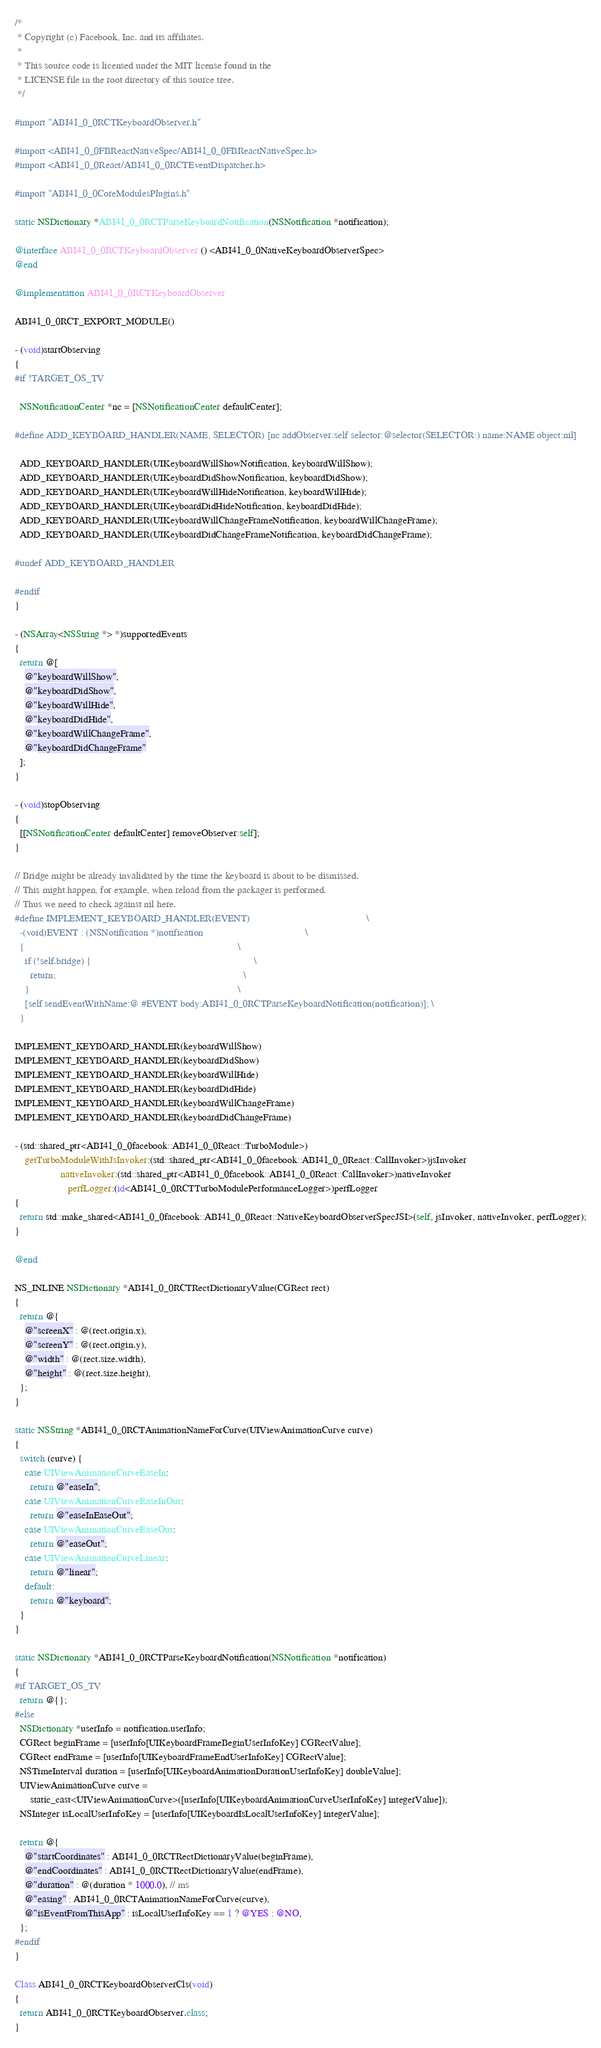<code> <loc_0><loc_0><loc_500><loc_500><_ObjectiveC_>/*
 * Copyright (c) Facebook, Inc. and its affiliates.
 *
 * This source code is licensed under the MIT license found in the
 * LICENSE file in the root directory of this source tree.
 */

#import "ABI41_0_0RCTKeyboardObserver.h"

#import <ABI41_0_0FBReactNativeSpec/ABI41_0_0FBReactNativeSpec.h>
#import <ABI41_0_0React/ABI41_0_0RCTEventDispatcher.h>

#import "ABI41_0_0CoreModulesPlugins.h"

static NSDictionary *ABI41_0_0RCTParseKeyboardNotification(NSNotification *notification);

@interface ABI41_0_0RCTKeyboardObserver () <ABI41_0_0NativeKeyboardObserverSpec>
@end

@implementation ABI41_0_0RCTKeyboardObserver

ABI41_0_0RCT_EXPORT_MODULE()

- (void)startObserving
{
#if !TARGET_OS_TV

  NSNotificationCenter *nc = [NSNotificationCenter defaultCenter];

#define ADD_KEYBOARD_HANDLER(NAME, SELECTOR) [nc addObserver:self selector:@selector(SELECTOR:) name:NAME object:nil]

  ADD_KEYBOARD_HANDLER(UIKeyboardWillShowNotification, keyboardWillShow);
  ADD_KEYBOARD_HANDLER(UIKeyboardDidShowNotification, keyboardDidShow);
  ADD_KEYBOARD_HANDLER(UIKeyboardWillHideNotification, keyboardWillHide);
  ADD_KEYBOARD_HANDLER(UIKeyboardDidHideNotification, keyboardDidHide);
  ADD_KEYBOARD_HANDLER(UIKeyboardWillChangeFrameNotification, keyboardWillChangeFrame);
  ADD_KEYBOARD_HANDLER(UIKeyboardDidChangeFrameNotification, keyboardDidChangeFrame);

#undef ADD_KEYBOARD_HANDLER

#endif
}

- (NSArray<NSString *> *)supportedEvents
{
  return @[
    @"keyboardWillShow",
    @"keyboardDidShow",
    @"keyboardWillHide",
    @"keyboardDidHide",
    @"keyboardWillChangeFrame",
    @"keyboardDidChangeFrame"
  ];
}

- (void)stopObserving
{
  [[NSNotificationCenter defaultCenter] removeObserver:self];
}

// Bridge might be already invalidated by the time the keyboard is about to be dismissed.
// This might happen, for example, when reload from the packager is performed.
// Thus we need to check against nil here.
#define IMPLEMENT_KEYBOARD_HANDLER(EVENT)                                              \
  -(void)EVENT : (NSNotification *)notification                                        \
  {                                                                                    \
    if (!self.bridge) {                                                                \
      return;                                                                          \
    }                                                                                  \
    [self sendEventWithName:@ #EVENT body:ABI41_0_0RCTParseKeyboardNotification(notification)]; \
  }

IMPLEMENT_KEYBOARD_HANDLER(keyboardWillShow)
IMPLEMENT_KEYBOARD_HANDLER(keyboardDidShow)
IMPLEMENT_KEYBOARD_HANDLER(keyboardWillHide)
IMPLEMENT_KEYBOARD_HANDLER(keyboardDidHide)
IMPLEMENT_KEYBOARD_HANDLER(keyboardWillChangeFrame)
IMPLEMENT_KEYBOARD_HANDLER(keyboardDidChangeFrame)

- (std::shared_ptr<ABI41_0_0facebook::ABI41_0_0React::TurboModule>)
    getTurboModuleWithJsInvoker:(std::shared_ptr<ABI41_0_0facebook::ABI41_0_0React::CallInvoker>)jsInvoker
                  nativeInvoker:(std::shared_ptr<ABI41_0_0facebook::ABI41_0_0React::CallInvoker>)nativeInvoker
                     perfLogger:(id<ABI41_0_0RCTTurboModulePerformanceLogger>)perfLogger
{
  return std::make_shared<ABI41_0_0facebook::ABI41_0_0React::NativeKeyboardObserverSpecJSI>(self, jsInvoker, nativeInvoker, perfLogger);
}

@end

NS_INLINE NSDictionary *ABI41_0_0RCTRectDictionaryValue(CGRect rect)
{
  return @{
    @"screenX" : @(rect.origin.x),
    @"screenY" : @(rect.origin.y),
    @"width" : @(rect.size.width),
    @"height" : @(rect.size.height),
  };
}

static NSString *ABI41_0_0RCTAnimationNameForCurve(UIViewAnimationCurve curve)
{
  switch (curve) {
    case UIViewAnimationCurveEaseIn:
      return @"easeIn";
    case UIViewAnimationCurveEaseInOut:
      return @"easeInEaseOut";
    case UIViewAnimationCurveEaseOut:
      return @"easeOut";
    case UIViewAnimationCurveLinear:
      return @"linear";
    default:
      return @"keyboard";
  }
}

static NSDictionary *ABI41_0_0RCTParseKeyboardNotification(NSNotification *notification)
{
#if TARGET_OS_TV
  return @{};
#else
  NSDictionary *userInfo = notification.userInfo;
  CGRect beginFrame = [userInfo[UIKeyboardFrameBeginUserInfoKey] CGRectValue];
  CGRect endFrame = [userInfo[UIKeyboardFrameEndUserInfoKey] CGRectValue];
  NSTimeInterval duration = [userInfo[UIKeyboardAnimationDurationUserInfoKey] doubleValue];
  UIViewAnimationCurve curve =
      static_cast<UIViewAnimationCurve>([userInfo[UIKeyboardAnimationCurveUserInfoKey] integerValue]);
  NSInteger isLocalUserInfoKey = [userInfo[UIKeyboardIsLocalUserInfoKey] integerValue];

  return @{
    @"startCoordinates" : ABI41_0_0RCTRectDictionaryValue(beginFrame),
    @"endCoordinates" : ABI41_0_0RCTRectDictionaryValue(endFrame),
    @"duration" : @(duration * 1000.0), // ms
    @"easing" : ABI41_0_0RCTAnimationNameForCurve(curve),
    @"isEventFromThisApp" : isLocalUserInfoKey == 1 ? @YES : @NO,
  };
#endif
}

Class ABI41_0_0RCTKeyboardObserverCls(void)
{
  return ABI41_0_0RCTKeyboardObserver.class;
}
</code> 